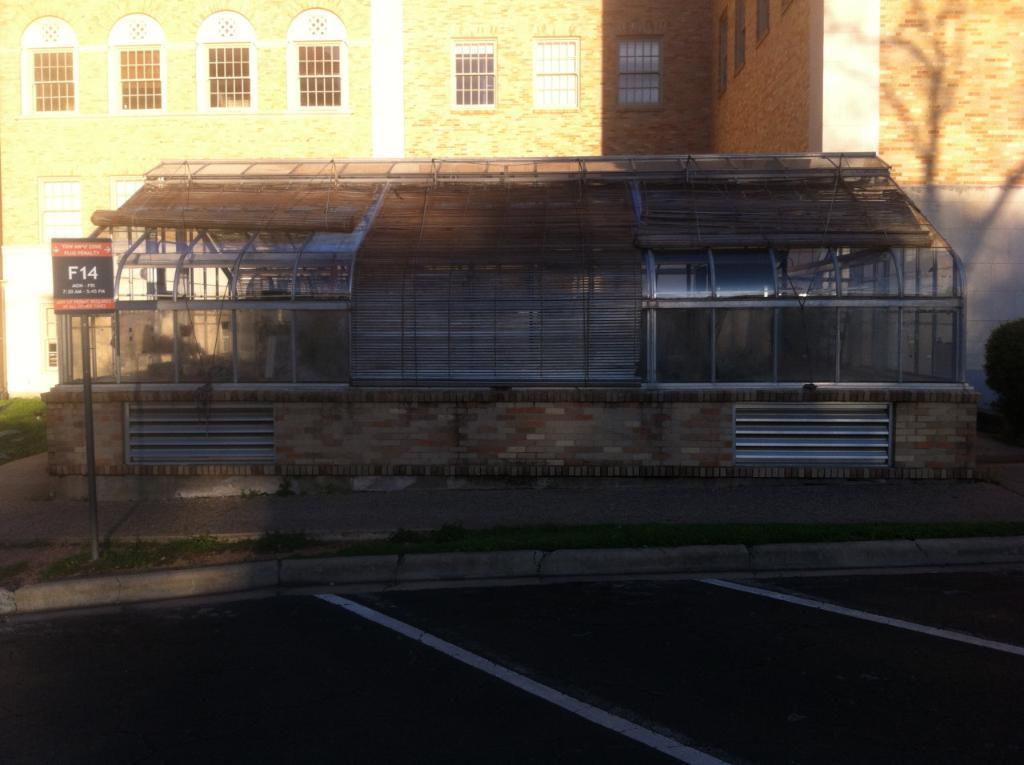In one or two sentences, can you explain what this image depicts? In this image there are some buildings in the center there is a house, on the left side there is pole and board. At the bottom there is road, and on the right side and left side there are some plants. 